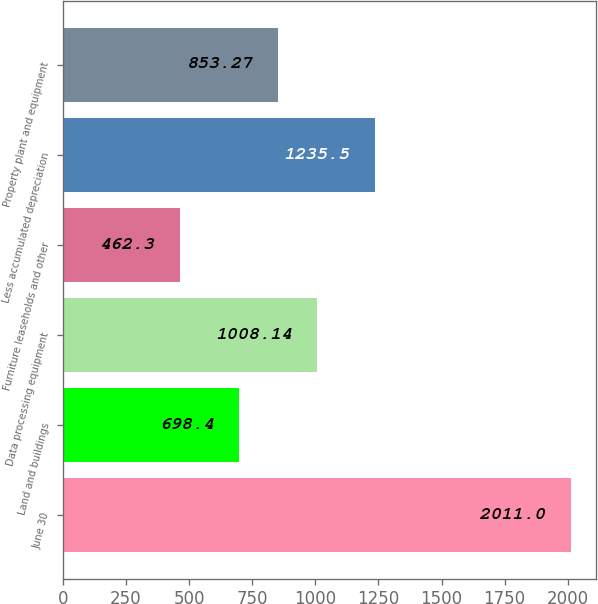Convert chart. <chart><loc_0><loc_0><loc_500><loc_500><bar_chart><fcel>June 30<fcel>Land and buildings<fcel>Data processing equipment<fcel>Furniture leaseholds and other<fcel>Less accumulated depreciation<fcel>Property plant and equipment<nl><fcel>2011<fcel>698.4<fcel>1008.14<fcel>462.3<fcel>1235.5<fcel>853.27<nl></chart> 